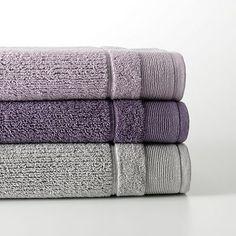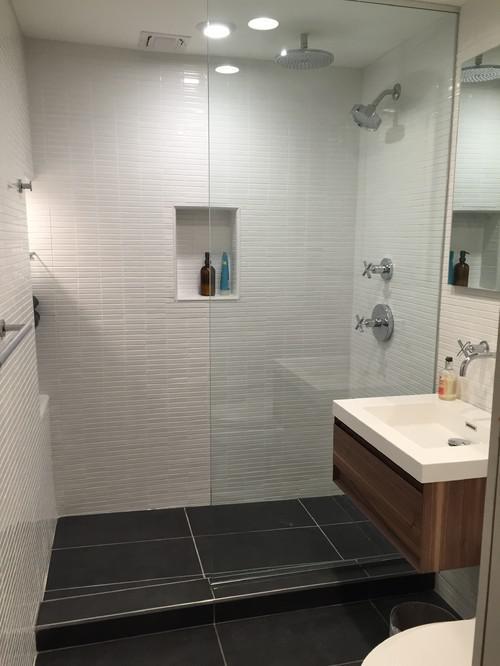The first image is the image on the left, the second image is the image on the right. For the images displayed, is the sentence "In one image, two towels hang side by side on one bar." factually correct? Answer yes or no. No. The first image is the image on the left, the second image is the image on the right. For the images displayed, is the sentence "A wall mounted bathroom sink is in one image." factually correct? Answer yes or no. Yes. 